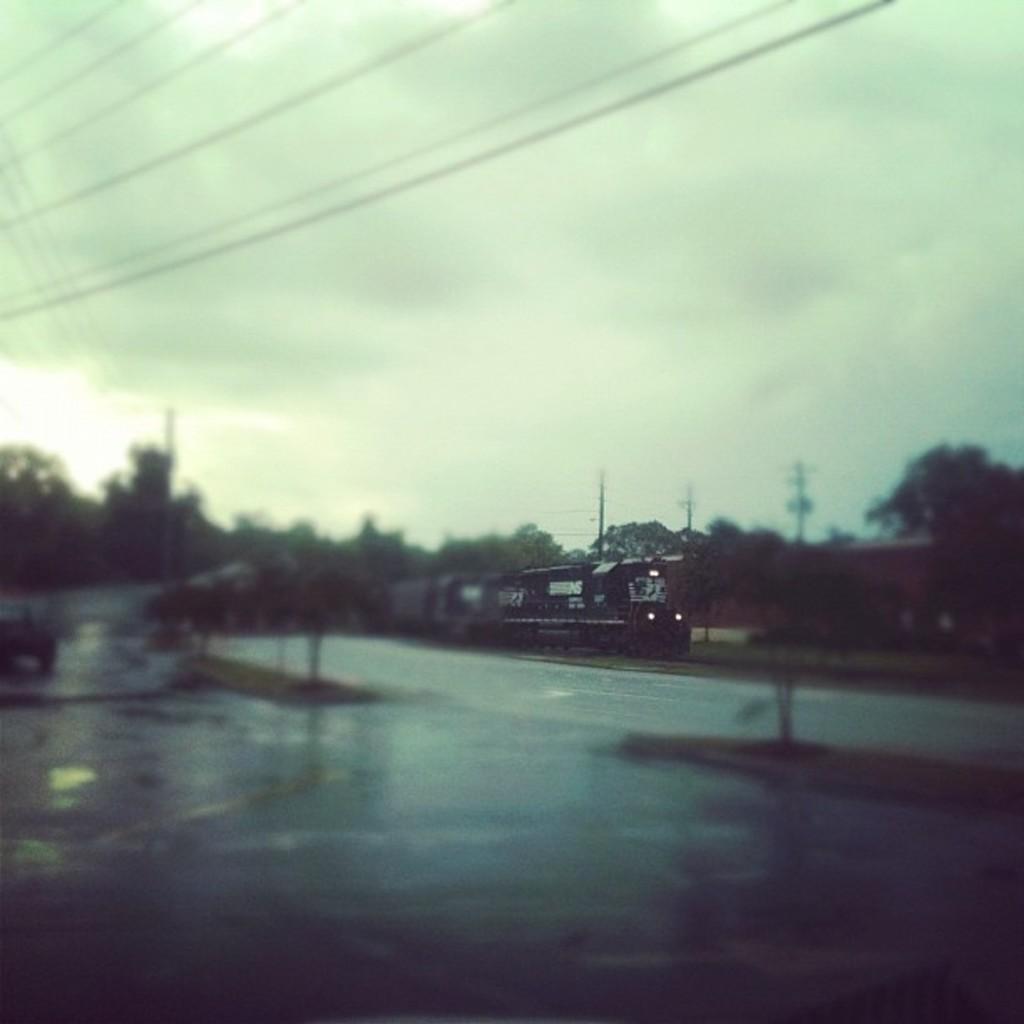How would you summarize this image in a sentence or two? In this picture I can see there is a train moving here and there are some plants, trees, electric poles and the sky is cloudy. 